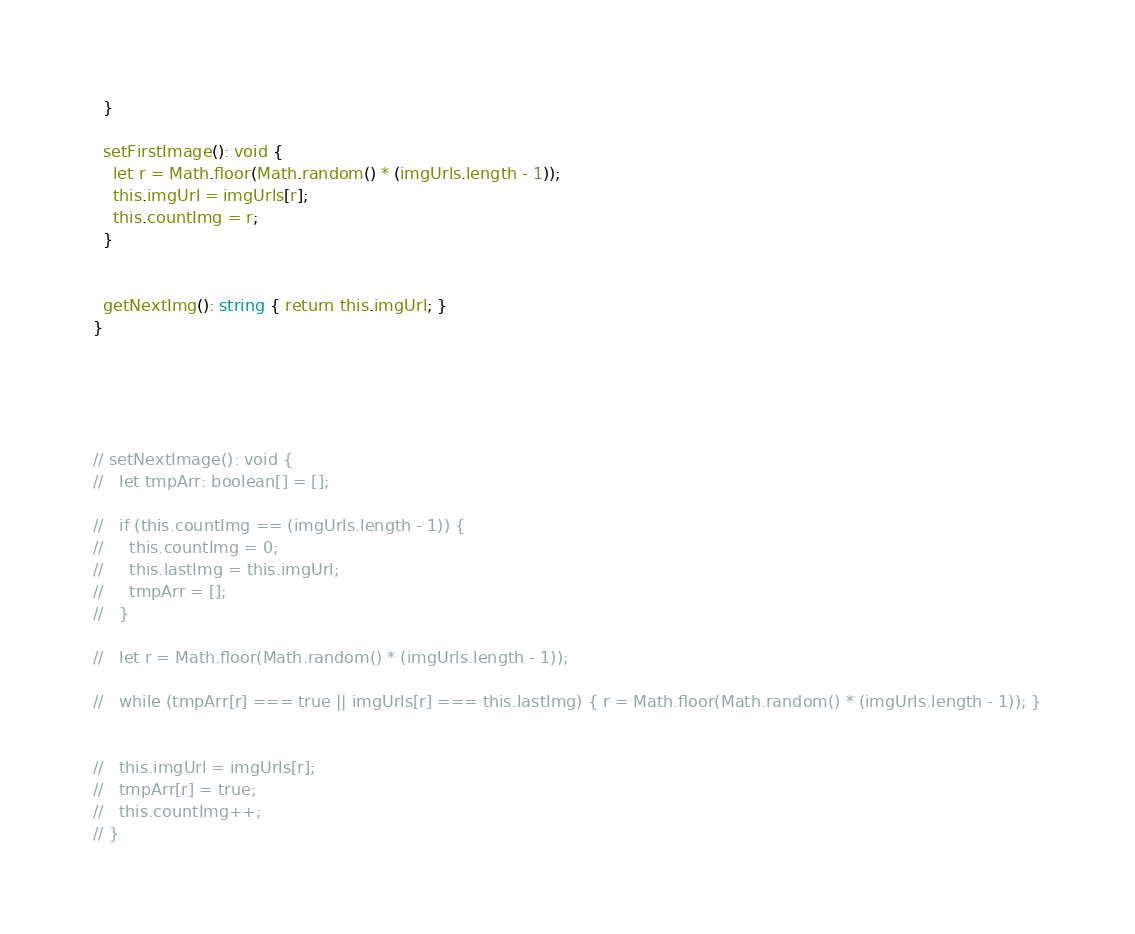Convert code to text. <code><loc_0><loc_0><loc_500><loc_500><_TypeScript_>  }

  setFirstImage(): void {
    let r = Math.floor(Math.random() * (imgUrls.length - 1));
    this.imgUrl = imgUrls[r];
    this.countImg = r;
  }


  getNextImg(): string { return this.imgUrl; }
}





// setNextImage(): void {
//   let tmpArr: boolean[] = [];

//   if (this.countImg == (imgUrls.length - 1)) {
//     this.countImg = 0;
//     this.lastImg = this.imgUrl;
//     tmpArr = [];
//   }

//   let r = Math.floor(Math.random() * (imgUrls.length - 1));

//   while (tmpArr[r] === true || imgUrls[r] === this.lastImg) { r = Math.floor(Math.random() * (imgUrls.length - 1)); }


//   this.imgUrl = imgUrls[r];
//   tmpArr[r] = true;
//   this.countImg++;
// }</code> 